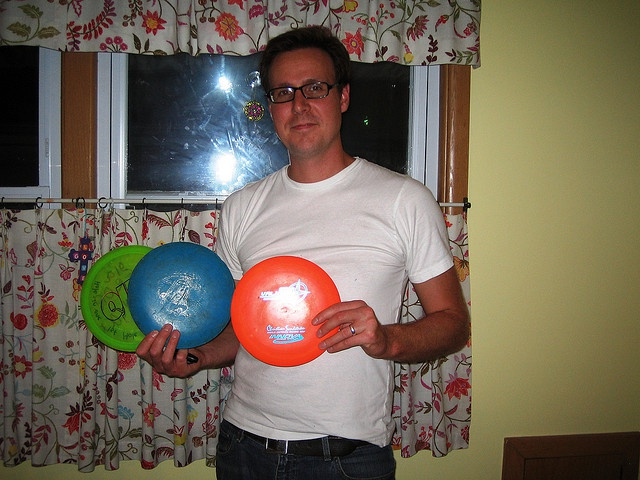Describe the objects in this image and their specific colors. I can see people in black, darkgray, lightgray, and maroon tones, frisbee in black, red, salmon, and white tones, frisbee in black, blue, teal, and gray tones, and frisbee in black, darkgreen, and green tones in this image. 